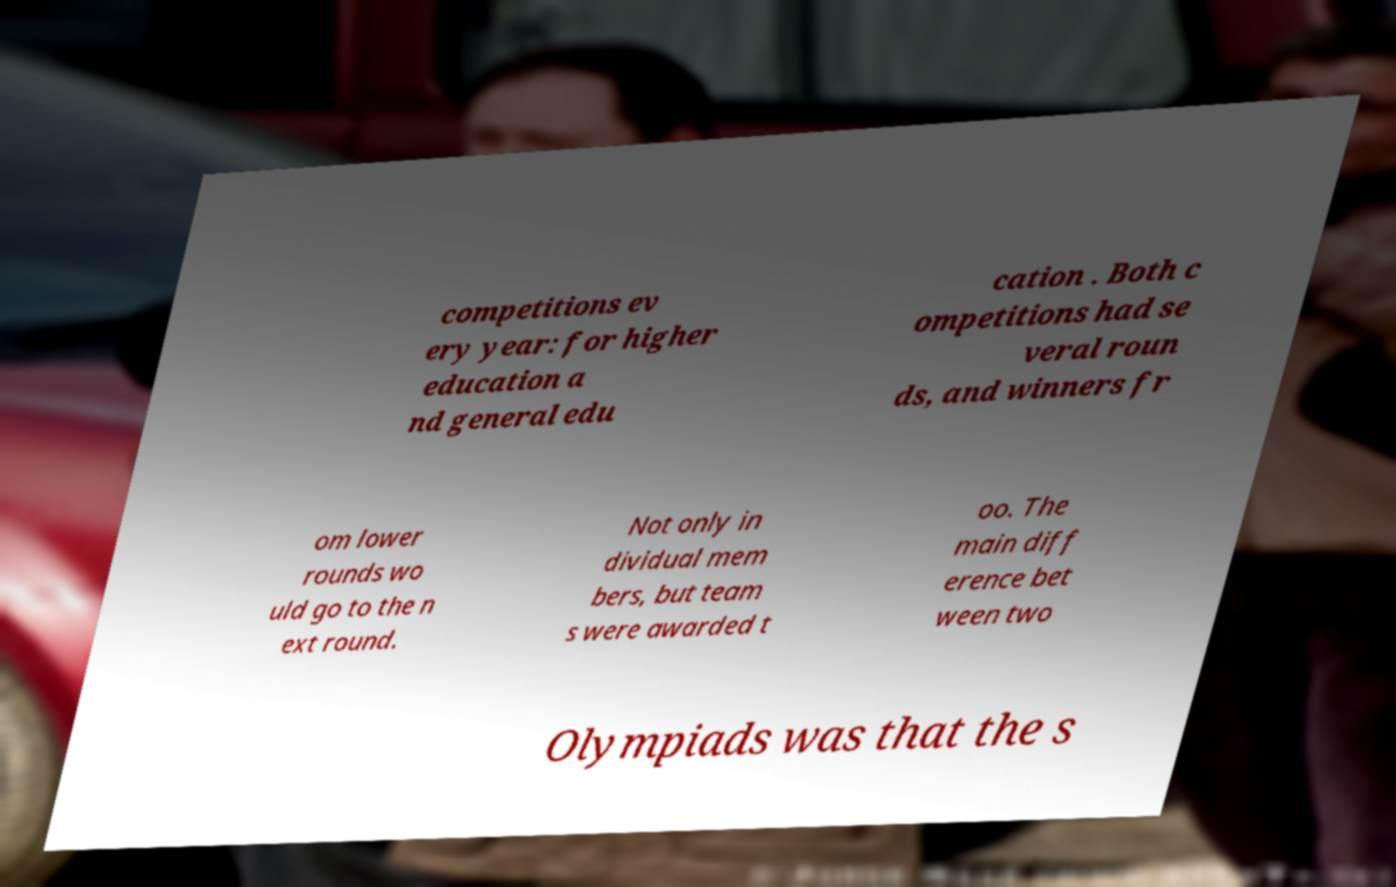What messages or text are displayed in this image? I need them in a readable, typed format. competitions ev ery year: for higher education a nd general edu cation . Both c ompetitions had se veral roun ds, and winners fr om lower rounds wo uld go to the n ext round. Not only in dividual mem bers, but team s were awarded t oo. The main diff erence bet ween two Olympiads was that the s 